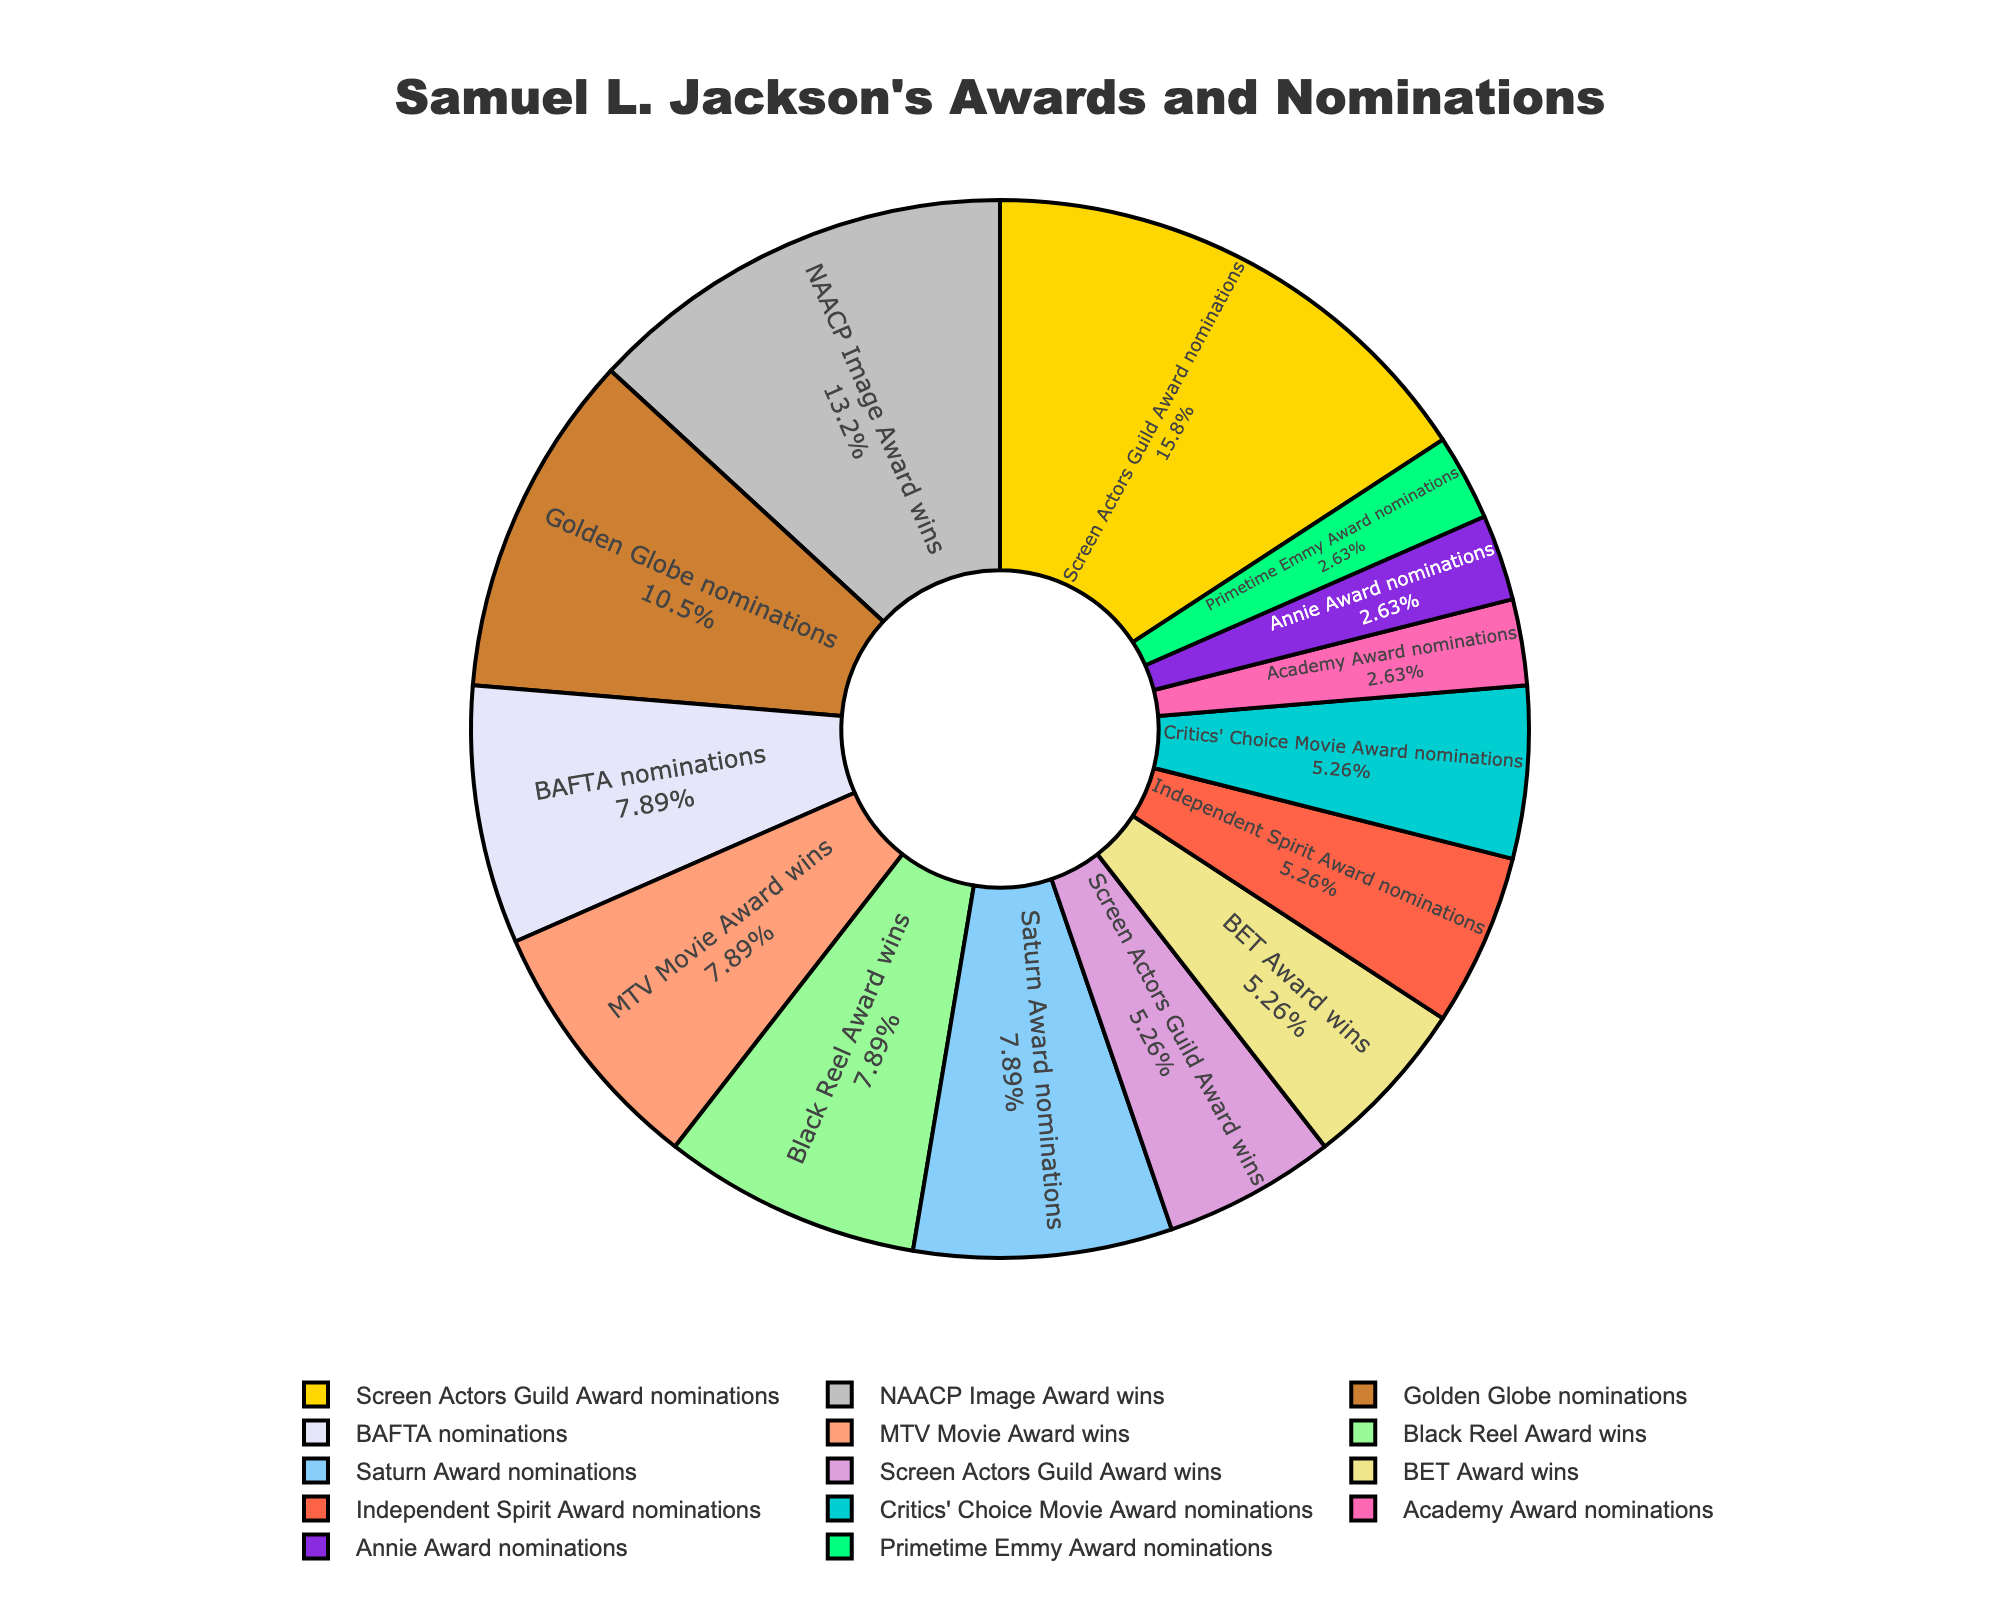Which category has the highest count? The category with the highest count is the largest segment in the pie chart.
Answer: Screen Actors Guild Award nominations Which category has the lowest count? The category with the lowest count is the smallest segment in the pie chart.
Answer: Academy Award nominations, Annie Award nominations, Primetime Emmy Award nominations How many total nominations and wins does Samuel L. Jackson have according to the chart? To find the total, sum up the counts of all categories shown in the pie chart. (1 + 3 + 4 + 2 + 6 + 3 + 5 + 2 + 3 + 2 + 3 + 2 + 1 + 1) = 38
Answer: 38 What is the difference between the number of Screen Actors Guild Award nominations and Screen Actors Guild Award wins? Screen Actors Guild Award nominations have a count of 6 and Screen Actors Guild Award wins have a count of 2. Subtract the wins from the nominations (6 - 2).
Answer: 4 Which category is visually represented by the golden color? The golden color segment in the pie chart corresponds to the largest category, which can be identified by the legend and segment size.
Answer: Screen Actors Guild Award nominations Are there more Golden Globe nominations or BAFTA nominations? Compare the segments labeled Golden Globe nominations and BAFTA nominations; Golden Globe nominations are 4 and BAFTA nominations are 3.
Answer: Golden Globe nominations What is the total number of wins (including all categories)? Add up the counts of all categories labeled as wins (Screen Actors Guild Award wins, MTV Movie Award wins, NAACP Image Award wins, BET Award wins, Black Reel Award wins). (2 + 3 + 5 + 2 + 3) = 15
Answer: 15 What percentage of the total awards and nominations does the Black Reel Award wins category represent? Divide the count of Black Reel Award wins by the total count and multiply by 100 (3 / 38) * 100 ≈ 7.89%. The exact number can be verified by looking at the text on the segment of the pie chart.
Answer: 7.89% Which has more: the sum of BET Award wins and NAACP Image Award wins or the sum of BAFTA nominations and Golden Globe nominations? Calculate the sum of BET Award wins and NAACP Image Award wins (2 + 5 = 7) and BAFTA nominations and Golden Globe nominations (3 + 4 = 7). Then compare the two sums.
Answer: They are equal Is the count of Independent Spirit Award nominations greater than the count of Critics' Choice Movie Award nominations? Compare the segments labeled Independent Spirit Award nominations (count of 2) and Critics' Choice Movie Award nominations (count of 2).
Answer: No, they are equal 